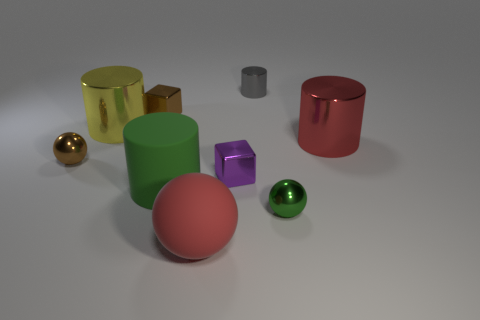Subtract all green cylinders. How many cylinders are left? 3 Subtract all cylinders. How many objects are left? 5 Subtract 1 balls. How many balls are left? 2 Subtract all red spheres. How many spheres are left? 2 Subtract all yellow blocks. Subtract all purple cylinders. How many blocks are left? 2 Subtract all gray cylinders. How many brown cubes are left? 1 Subtract all tiny yellow things. Subtract all big spheres. How many objects are left? 8 Add 6 red objects. How many red objects are left? 8 Add 5 small green cylinders. How many small green cylinders exist? 5 Subtract 1 green balls. How many objects are left? 8 